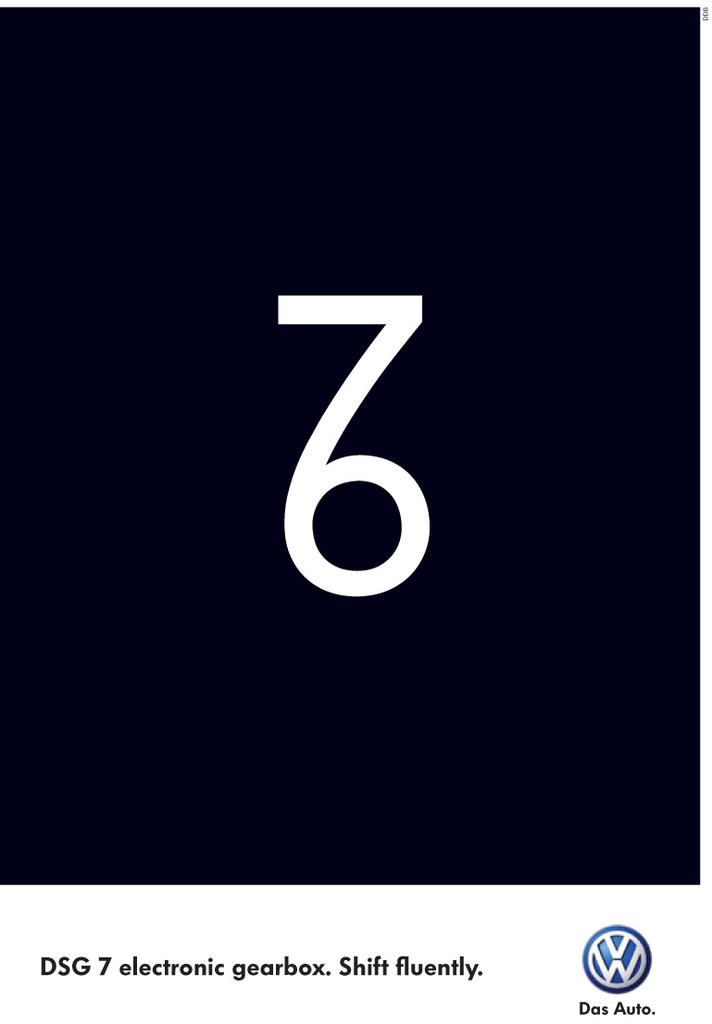<image>
Summarize the visual content of the image. A Volkswagen  sponsored add for DSG 7 electronic gearbox. 